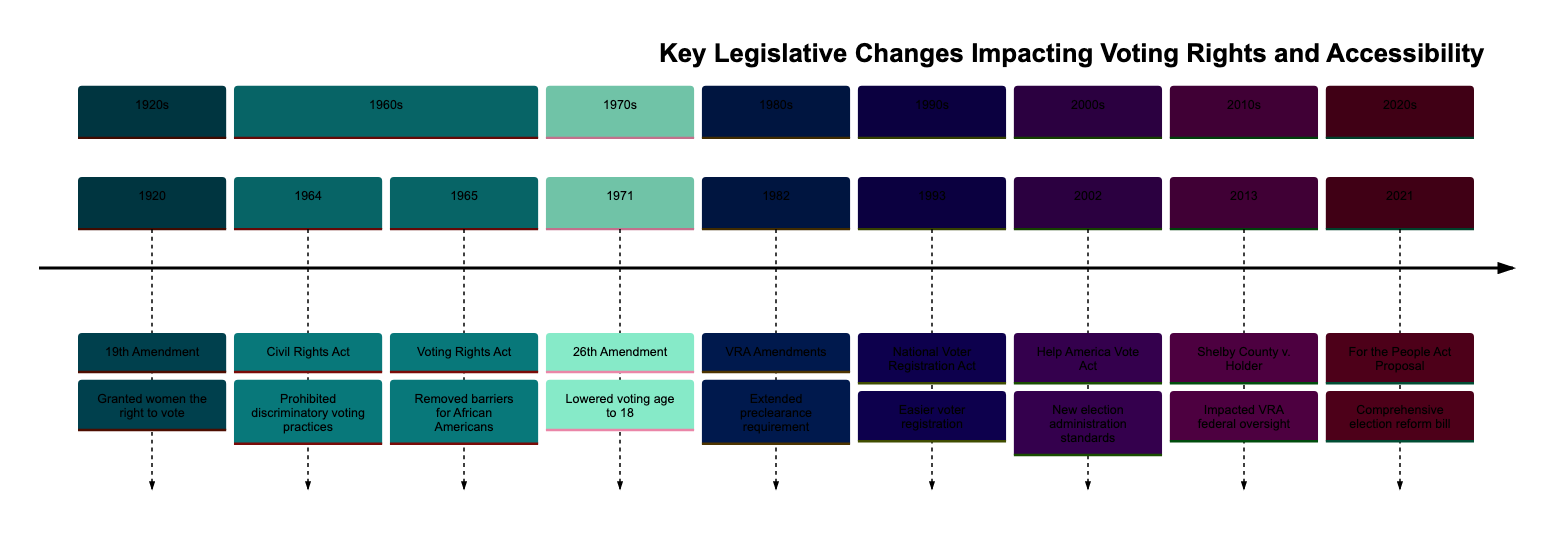What event occurred in 1920? The diagram states that in 1920, the event is the "19th Amendment," which granted women the right to vote in the United States.
Answer: 19th Amendment How many events are listed in the 1960s? By counting the events listed in the 1960s section of the diagram, there are two events: the "Civil Rights Act" in 1964 and the "Voting Rights Act" in 1965.
Answer: 2 What was the impact of the 2013 decision on the Voting Rights Act? The "Shelby County v. Holder" decision invalidated key provisions of the Voting Rights Act of 1965, which primarily affected federal oversight of voting changes as conveyed in the description.
Answer: Impacted federal oversight Which legislative change lowered the voting age? The "26th Amendment" in 1971 is specifically mentioned as lowering the voting age from 21 to 18.
Answer: 26th Amendment What legislation was proposed in 2021? The diagram highlights the "For the People Act Proposal" as the comprehensive election reform bill intended to expand voting rights and change campaign finance laws in 2021.
Answer: For the People Act Proposal What amendment extended the preclearance requirement in the 1980s? The "Voting Rights Act Amendments" in 1982 extended Section 5 preclearance requirements for another 25 years to prevent discriminatory practices, as detailed in the description.
Answer: VRA Amendments Which act made voter registration easier? The "National Voter Registration Act" in 1993 made it easier for Americans to register to vote and maintain their registration.
Answer: National Voter Registration Act Identify the legislative change that occurred directly after the 1965 Voting Rights Act. Following the 1965 Voting Rights Act, the next event chronologically is the "26th Amendment" in 1971, which is directly after.
Answer: 26th Amendment 